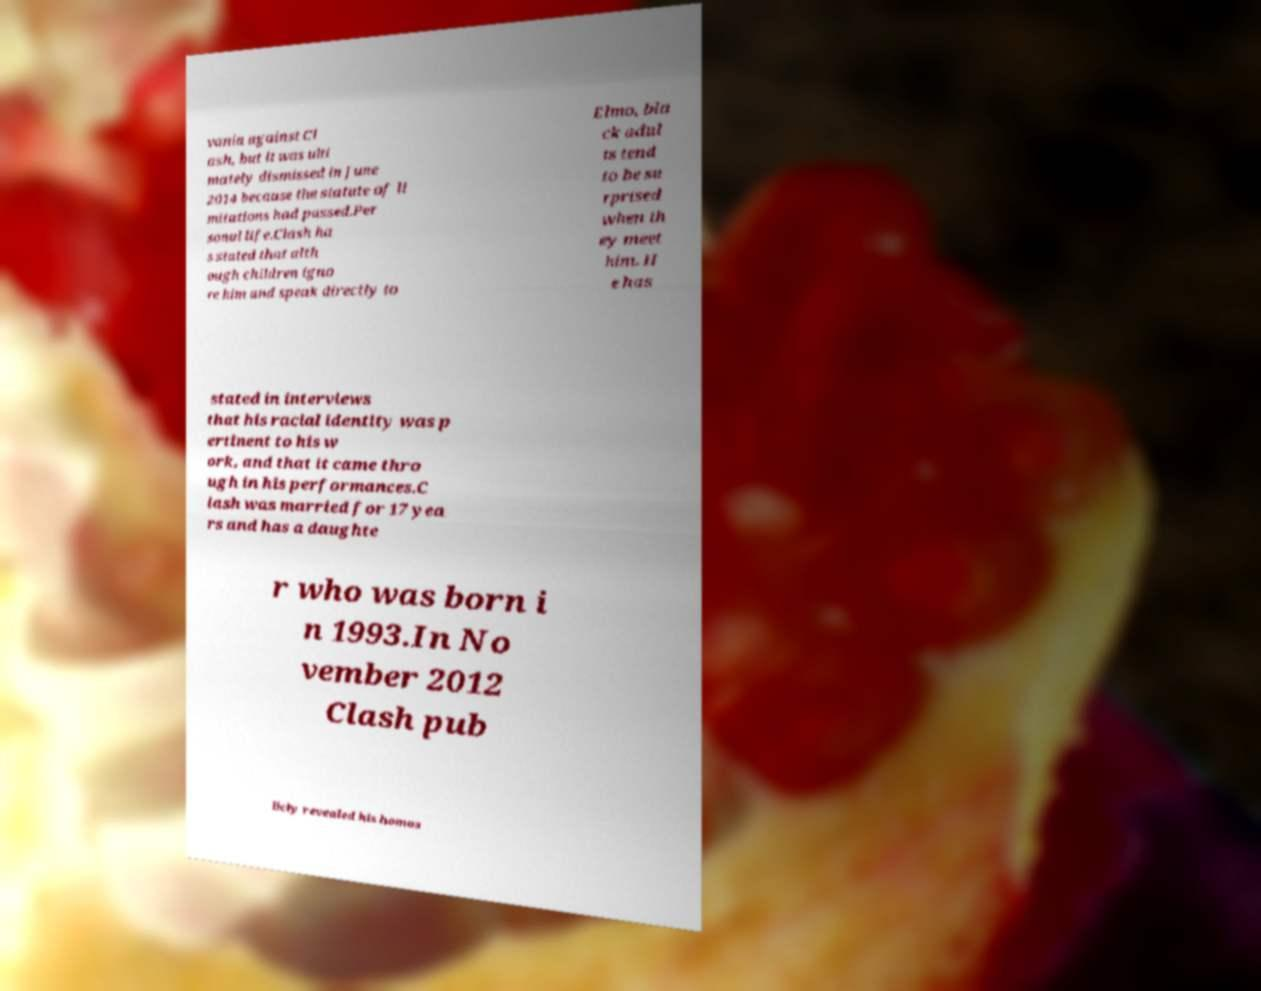Can you accurately transcribe the text from the provided image for me? vania against Cl ash, but it was ulti mately dismissed in June 2014 because the statute of li mitations had passed.Per sonal life.Clash ha s stated that alth ough children igno re him and speak directly to Elmo, bla ck adul ts tend to be su rprised when th ey meet him. H e has stated in interviews that his racial identity was p ertinent to his w ork, and that it came thro ugh in his performances.C lash was married for 17 yea rs and has a daughte r who was born i n 1993.In No vember 2012 Clash pub licly revealed his homos 